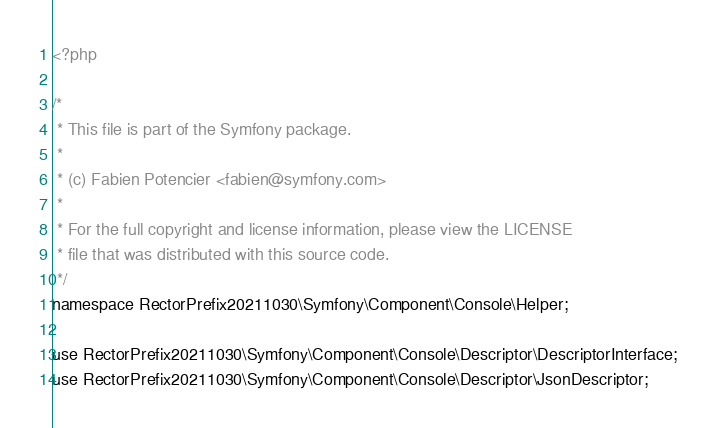<code> <loc_0><loc_0><loc_500><loc_500><_PHP_><?php

/*
 * This file is part of the Symfony package.
 *
 * (c) Fabien Potencier <fabien@symfony.com>
 *
 * For the full copyright and license information, please view the LICENSE
 * file that was distributed with this source code.
 */
namespace RectorPrefix20211030\Symfony\Component\Console\Helper;

use RectorPrefix20211030\Symfony\Component\Console\Descriptor\DescriptorInterface;
use RectorPrefix20211030\Symfony\Component\Console\Descriptor\JsonDescriptor;</code> 